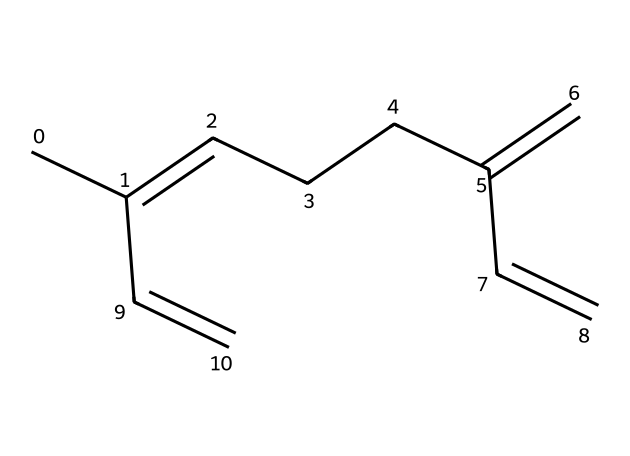How many carbon atoms are in myrcene? By analyzing the SMILES representation, CC(=CCCC(=C)C=C), you can count the carbon atoms. Each 'C' in the SMILES indicates a carbon atom. There are 10 'C' present in the structure, indicating that there are 10 carbon atoms.
Answer: 10 What is the main functional group in myrcene? The structure shows a series of double bonds (=C), indicating that myrcene primarily contains alkenes. The presence of multiple cis/trans double bonds in its structure is characteristic of this type of compound.
Answer: alkenes How many double bonds are in myrcene? Observing the structure, there are three double bonds represented as (=). Counting each occurrence in the SMILES, we see three instances, thus confirming the number of double bonds in myrcene.
Answer: 3 Is myrcene a cyclic or acyclic compound? The SMILES notation does not indicate any cyclical structures, as there are no enclosed rings. This confirms that the structure is linear and does not form a cycle, classifying it as acyclic.
Answer: acyclic What type of terpene is myrcene? Myrcene is classified as a monoterpene because it contains 10 carbon atoms, which is typical for monoterpenes derived from the combination of two isoprene units (each contributing 5 carbon atoms).
Answer: monoterpene How does the structure of myrcene influence its aroma? The presence of alkene functional groups (double bonds) in the structure contributes to its strong aroma characteristics. This is a common trait in terpenes, where the arrangement of carbon chains and functional groups affects the scent profile.
Answer: aromatic qualities What fruit is myrcene commonly found in? The SMILES representation reveals the structure linked to tropical fruits, most notably mangoes, which is a common source known for high myrcene content and is a speaker in Brazilian cuisine and culture.
Answer: mangoes 